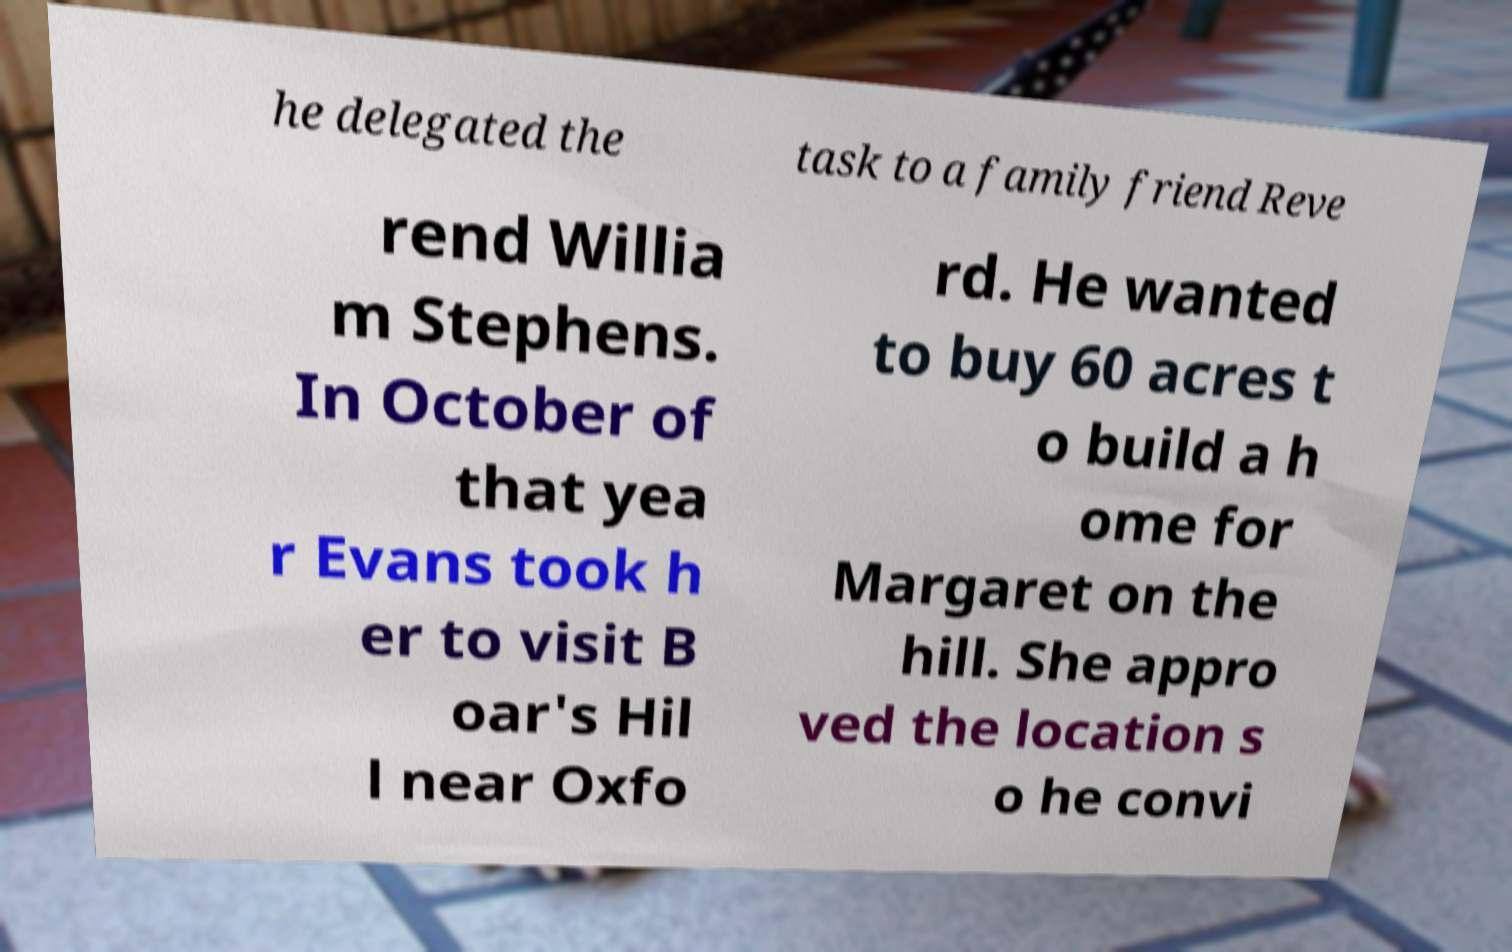Can you read and provide the text displayed in the image?This photo seems to have some interesting text. Can you extract and type it out for me? he delegated the task to a family friend Reve rend Willia m Stephens. In October of that yea r Evans took h er to visit B oar's Hil l near Oxfo rd. He wanted to buy 60 acres t o build a h ome for Margaret on the hill. She appro ved the location s o he convi 